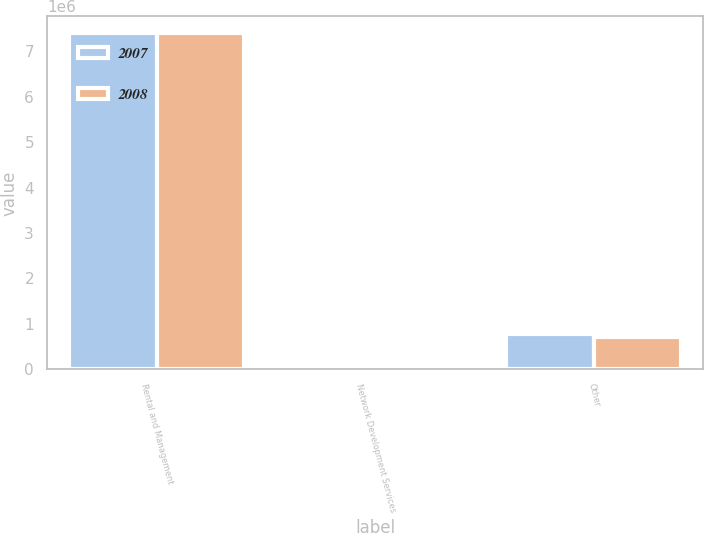Convert chart to OTSL. <chart><loc_0><loc_0><loc_500><loc_500><stacked_bar_chart><ecel><fcel>Rental and Management<fcel>Network Development Services<fcel>Other<nl><fcel>2007<fcel>7.39888e+06<fcel>35618<fcel>777170<nl><fcel>2008<fcel>7.39858e+06<fcel>30263<fcel>701613<nl></chart> 